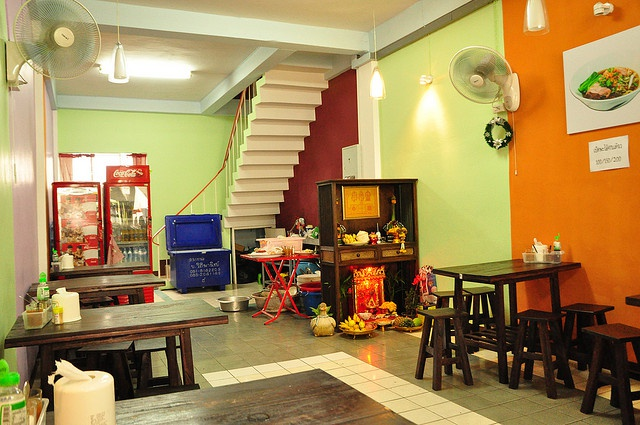Describe the objects in this image and their specific colors. I can see dining table in khaki, brown, gray, olive, and tan tones, dining table in khaki, black, tan, and maroon tones, dining table in khaki, black, olive, and maroon tones, refrigerator in khaki, tan, ivory, olive, and brown tones, and chair in khaki, black, and maroon tones in this image. 